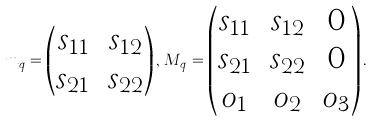Convert formula to latex. <formula><loc_0><loc_0><loc_500><loc_500>m _ { q } = \begin{pmatrix} s _ { 1 1 } & s _ { 1 2 } \\ s _ { 2 1 } & s _ { 2 2 } \end{pmatrix} , \, M _ { q } = \begin{pmatrix} s _ { 1 1 } & s _ { 1 2 } & 0 \\ s _ { 2 1 } & s _ { 2 2 } & 0 \\ o _ { 1 } & o _ { 2 } & o _ { 3 } \end{pmatrix} .</formula> 